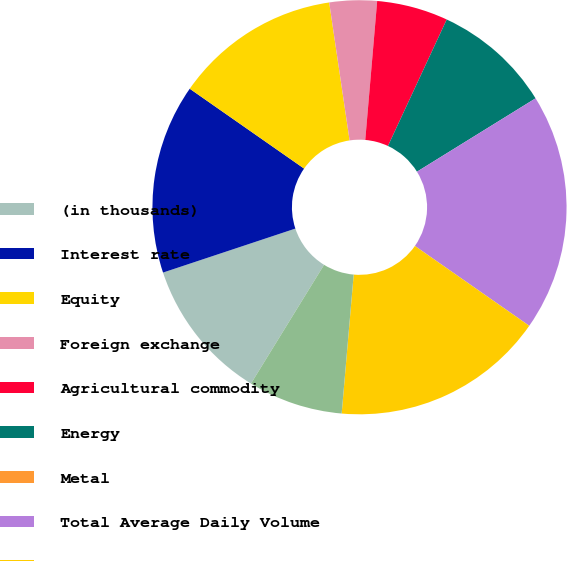<chart> <loc_0><loc_0><loc_500><loc_500><pie_chart><fcel>(in thousands)<fcel>Interest rate<fcel>Equity<fcel>Foreign exchange<fcel>Agricultural commodity<fcel>Energy<fcel>Metal<fcel>Total Average Daily Volume<fcel>Electronic<fcel>Open outcry<nl><fcel>11.11%<fcel>14.81%<fcel>12.96%<fcel>3.7%<fcel>5.56%<fcel>9.26%<fcel>0.0%<fcel>18.52%<fcel>16.67%<fcel>7.41%<nl></chart> 